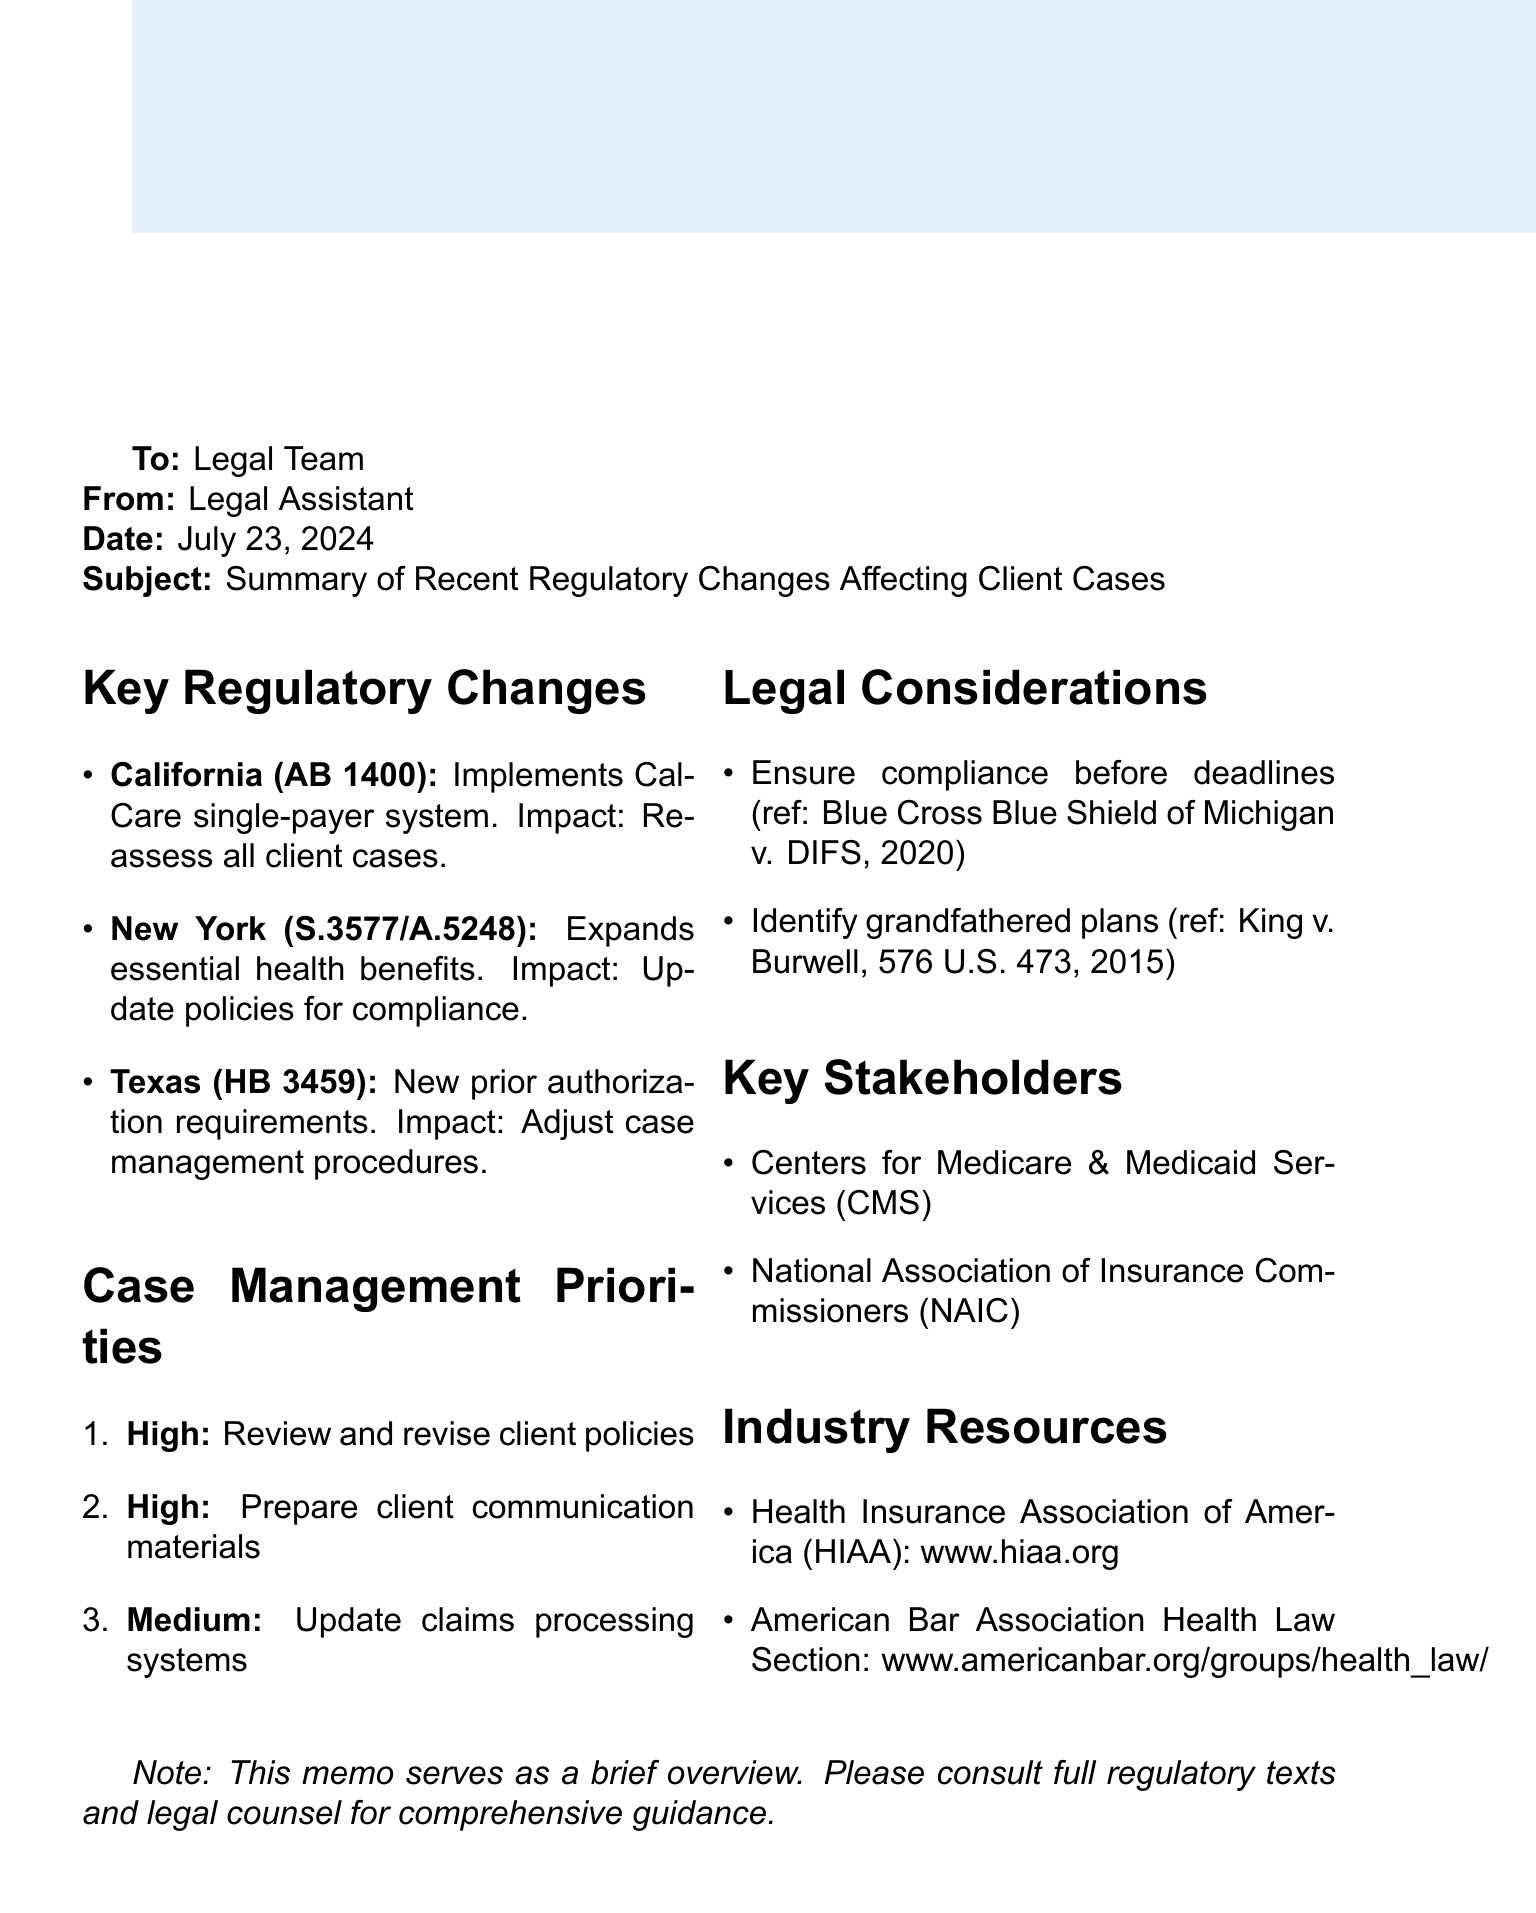What is the name of the regulation in California? The regulation mentioned for California is Assembly Bill 1400, which is specifically addressed in the document.
Answer: Assembly Bill 1400 What is the impact of the New York regulation? The document states that the impact of the New York regulation is the need to review and update client policies for compliance with new coverage requirements.
Answer: Update of client policies What is the priority level for client communication materials? The document indicates that client communication is listed as a high priority aspect in the case management considerations.
Answer: High What does HB 3459 implement in Texas? The document specifies that House Bill 3459 implements new prior authorization requirements for certain medical services.
Answer: New prior authorization requirements What case is referenced regarding compliance deadlines? The memo mentions a specific court case that is relevant to compliance deadlines which is useful for legal considerations.
Answer: Blue Cross Blue Shield of Michigan v. Department of Insurance and Financial Services How many key stakeholders are listed in the document? The document presents two key stakeholders that play a significant role in health insurance regulations.
Answer: Two What is one feature of the Health Insurance Association of America? The document describes a useful feature of the Health Insurance Association of America, which helps in regulatory updates.
Answer: Regulatory update database and compliance toolkits In which state is CalCare system implemented? The document notes that the CalCare single-payer healthcare system is implemented in California.
Answer: California What is the purpose of the American Bar Association Health Law Section? The document mentions that the American Bar Association Health Law Section offers resources helpful for those dealing with health insurance law changes.
Answer: Webinars and publications on health insurance law changes 